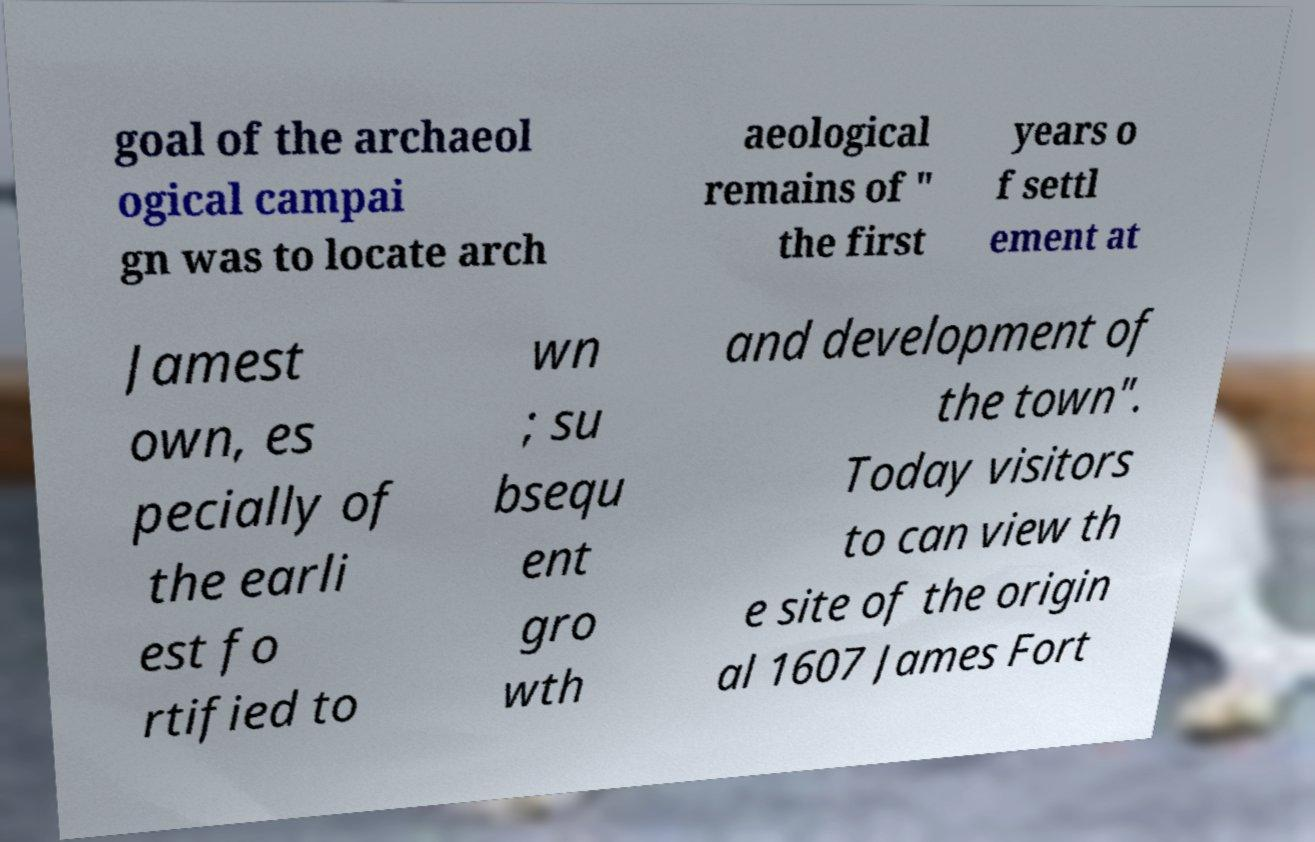I need the written content from this picture converted into text. Can you do that? goal of the archaeol ogical campai gn was to locate arch aeological remains of " the first years o f settl ement at Jamest own, es pecially of the earli est fo rtified to wn ; su bsequ ent gro wth and development of the town". Today visitors to can view th e site of the origin al 1607 James Fort 